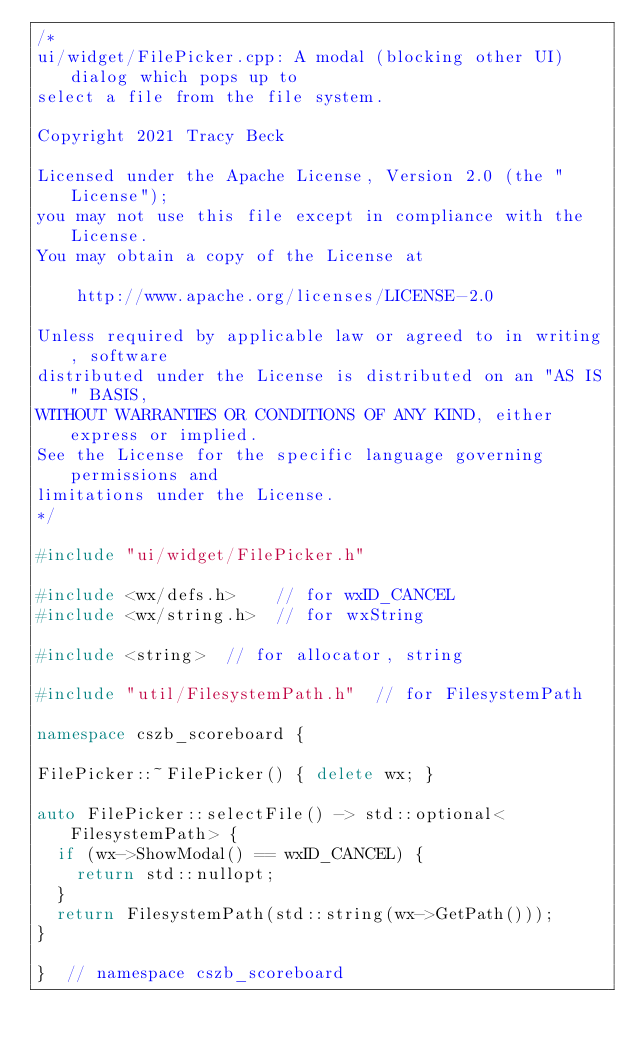Convert code to text. <code><loc_0><loc_0><loc_500><loc_500><_C++_>/*
ui/widget/FilePicker.cpp: A modal (blocking other UI) dialog which pops up to
select a file from the file system.

Copyright 2021 Tracy Beck

Licensed under the Apache License, Version 2.0 (the "License");
you may not use this file except in compliance with the License.
You may obtain a copy of the License at

    http://www.apache.org/licenses/LICENSE-2.0

Unless required by applicable law or agreed to in writing, software
distributed under the License is distributed on an "AS IS" BASIS,
WITHOUT WARRANTIES OR CONDITIONS OF ANY KIND, either express or implied.
See the License for the specific language governing permissions and
limitations under the License.
*/

#include "ui/widget/FilePicker.h"

#include <wx/defs.h>    // for wxID_CANCEL
#include <wx/string.h>  // for wxString

#include <string>  // for allocator, string

#include "util/FilesystemPath.h"  // for FilesystemPath

namespace cszb_scoreboard {

FilePicker::~FilePicker() { delete wx; }

auto FilePicker::selectFile() -> std::optional<FilesystemPath> {
  if (wx->ShowModal() == wxID_CANCEL) {
    return std::nullopt;
  }
  return FilesystemPath(std::string(wx->GetPath()));
}

}  // namespace cszb_scoreboard
</code> 